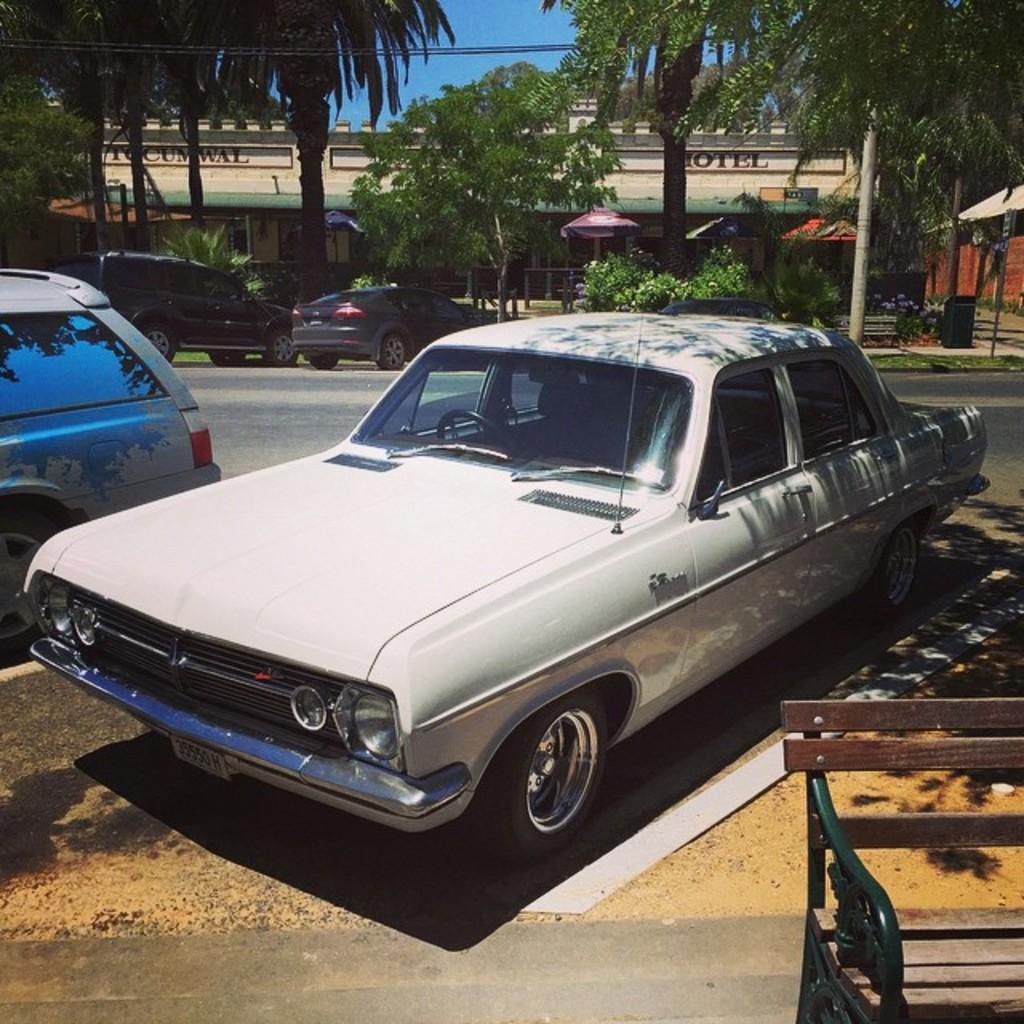Describe this image in one or two sentences. there is a car. in front of it there is a wooden bench. behind that there is a road and trees. behind the trees there is a building. 